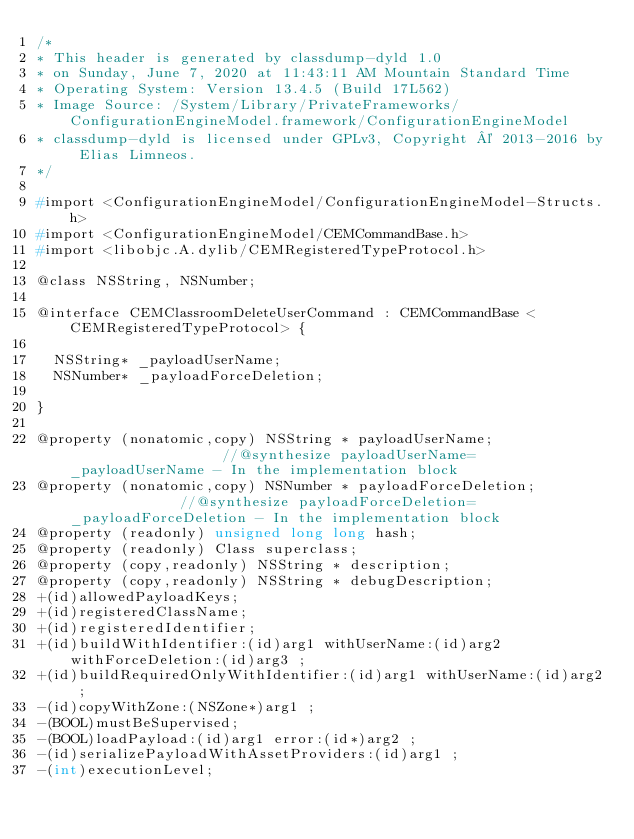<code> <loc_0><loc_0><loc_500><loc_500><_C_>/*
* This header is generated by classdump-dyld 1.0
* on Sunday, June 7, 2020 at 11:43:11 AM Mountain Standard Time
* Operating System: Version 13.4.5 (Build 17L562)
* Image Source: /System/Library/PrivateFrameworks/ConfigurationEngineModel.framework/ConfigurationEngineModel
* classdump-dyld is licensed under GPLv3, Copyright © 2013-2016 by Elias Limneos.
*/

#import <ConfigurationEngineModel/ConfigurationEngineModel-Structs.h>
#import <ConfigurationEngineModel/CEMCommandBase.h>
#import <libobjc.A.dylib/CEMRegisteredTypeProtocol.h>

@class NSString, NSNumber;

@interface CEMClassroomDeleteUserCommand : CEMCommandBase <CEMRegisteredTypeProtocol> {

	NSString* _payloadUserName;
	NSNumber* _payloadForceDeletion;

}

@property (nonatomic,copy) NSString * payloadUserName;                   //@synthesize payloadUserName=_payloadUserName - In the implementation block
@property (nonatomic,copy) NSNumber * payloadForceDeletion;              //@synthesize payloadForceDeletion=_payloadForceDeletion - In the implementation block
@property (readonly) unsigned long long hash; 
@property (readonly) Class superclass; 
@property (copy,readonly) NSString * description; 
@property (copy,readonly) NSString * debugDescription; 
+(id)allowedPayloadKeys;
+(id)registeredClassName;
+(id)registeredIdentifier;
+(id)buildWithIdentifier:(id)arg1 withUserName:(id)arg2 withForceDeletion:(id)arg3 ;
+(id)buildRequiredOnlyWithIdentifier:(id)arg1 withUserName:(id)arg2 ;
-(id)copyWithZone:(NSZone*)arg1 ;
-(BOOL)mustBeSupervised;
-(BOOL)loadPayload:(id)arg1 error:(id*)arg2 ;
-(id)serializePayloadWithAssetProviders:(id)arg1 ;
-(int)executionLevel;</code> 